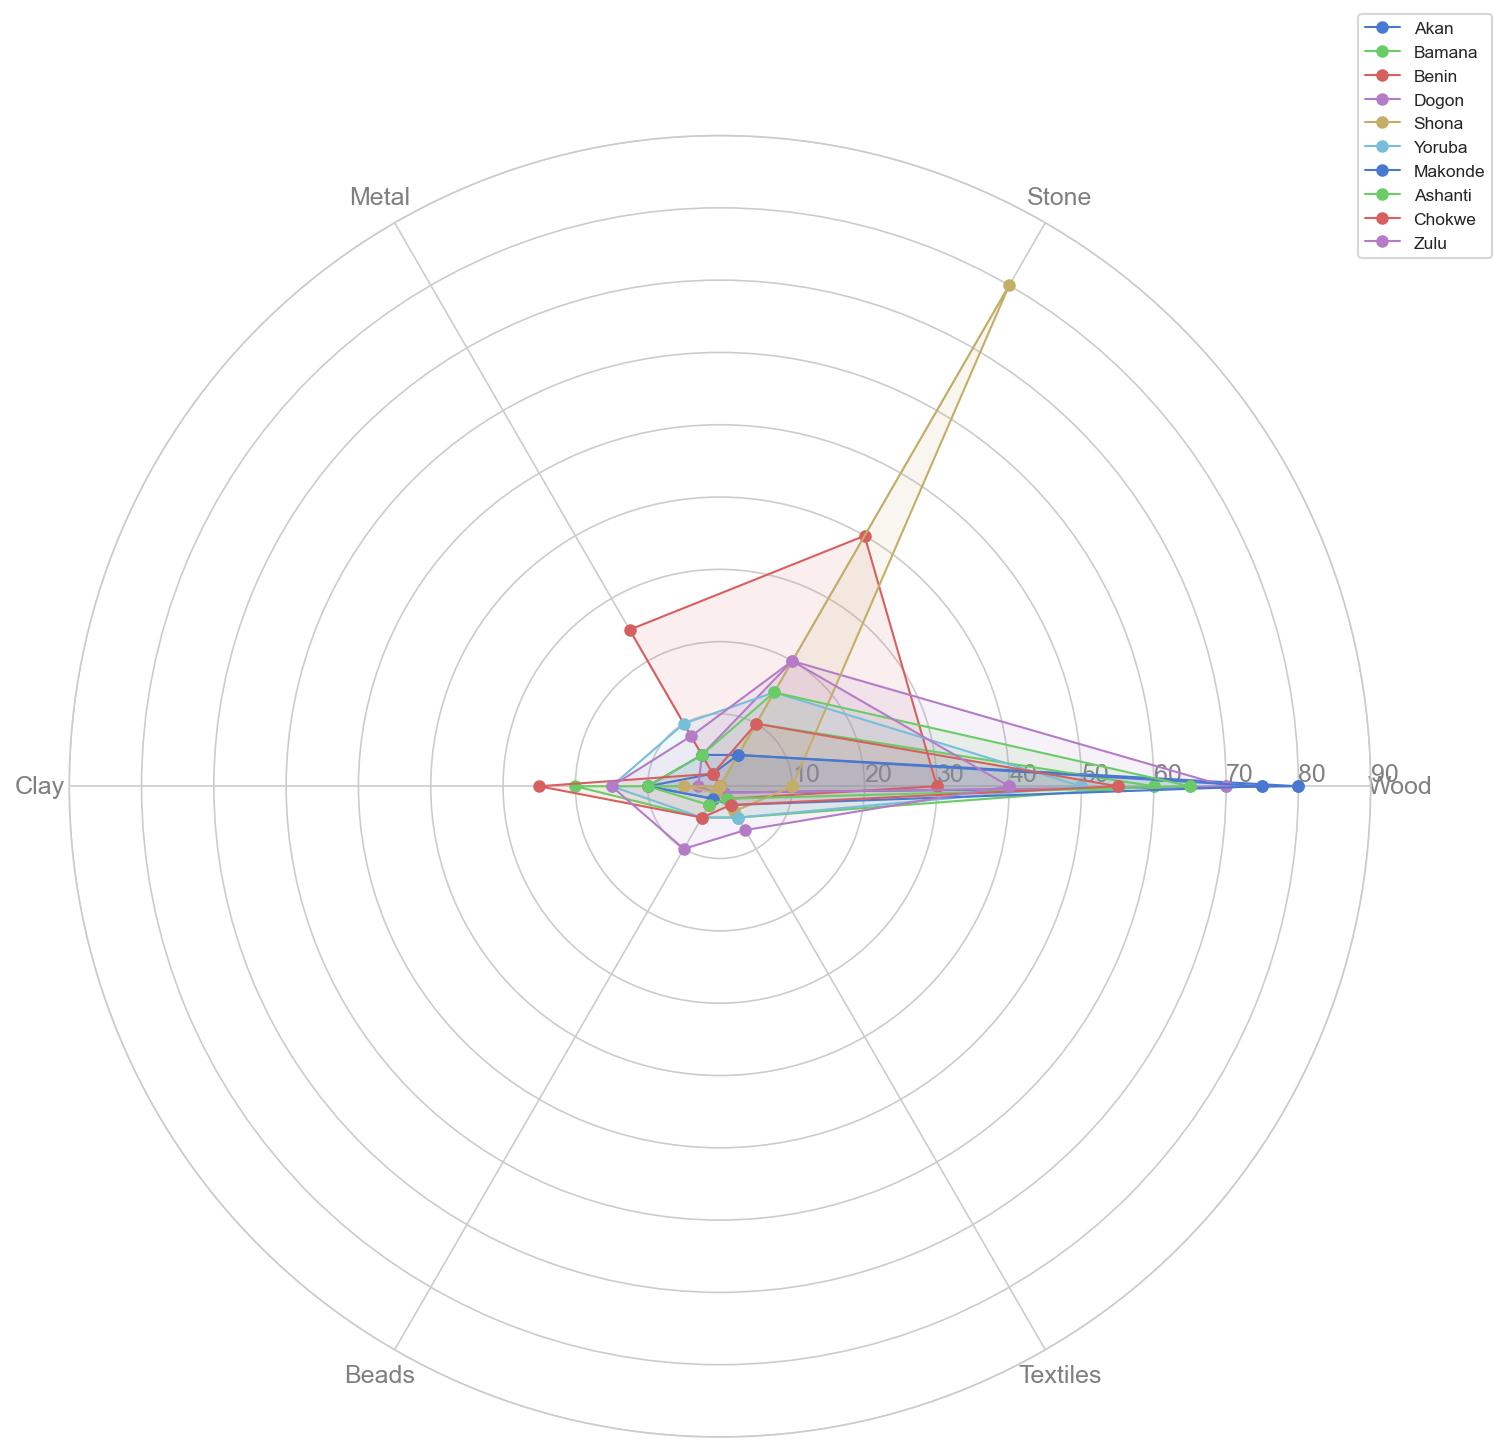What is the most frequently used material across all cultures? By observing the highest values on the radar chart for each material, we see that the largest single value is for Wood by the Akan culture at 80.
Answer: Wood Which culture uses Stone the most frequently? By examining the radar chart, we see that the Shona culture has the highest value for Stone at 80.
Answer: Shona Compare the usage of Clay between Akan and Bamana. Which culture utilizes it more, and by how much? The radar chart shows Akan's Clay usage at 10 and Bamana's at 20. Bamana uses Clay more, with a difference of 10 units.
Answer: Bamana, 10 Which materials do the Benin culture use more than the Yoruba culture? Observing the lines for Benin and Yoruba, Benin uses more Stone (40 vs 15) and Metal (25 vs 10).
Answer: Stone and Metal What is the average usage of Beads material across all cultures? Summing all the Beads usage values (2 + 5 + 3 + 1 + 1 + 5 + 2 + 3 + 5 + 10) gives 37. Dividing by the number of cultures (10) gives an average of 3.7.
Answer: 3.7 Among Zulu, Chokwe, and Ashanti cultures, which one has the highest diversity in using different materials? The radar chart shows that Zulu uses a wider range with visible use in all materials (Wood 40, Stone 20, Metal 8, Clay 15, Beads 10, Textiles 7). Comparatively, Chokwe and Ashanti have narrower ranges.
Answer: Zulu If you sum the usage of Textiles for Akan and Makonde, is it more or less than the sum of Textiles for Yoruba and Zulu? Akan and Makonde Textiles are 1 + 3 = 4, while Yoruba and Zulu Textiles are 5 + 7 = 12. Thus, it is less.
Answer: Less How does the frequency of Metal usage in Benin compare to that in Dogon? The radar chart shows Benin has a value of 25 for Metal, whereas Dogon has a value of 5. Benin uses Metal 20 units more than Dogon.
Answer: Benin, 20 Which culture uses the fewest materials with a frequency greater than 50? Observing the radar chart, Shona uses only Stone with a value of 80. Other materials are 10, 5, 1, 4, and 0, all less than 50.
Answer: Shona 